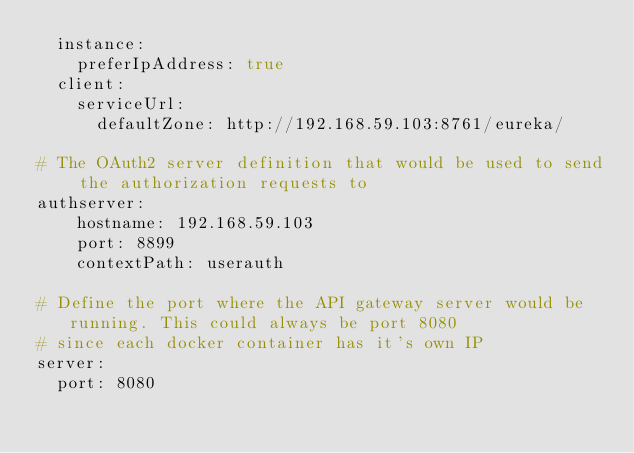<code> <loc_0><loc_0><loc_500><loc_500><_YAML_>  instance:
    preferIpAddress: true
  client:
    serviceUrl:
      defaultZone: http://192.168.59.103:8761/eureka/
      
# The OAuth2 server definition that would be used to send the authorization requests to
authserver:
    hostname: 192.168.59.103
    port: 8899
    contextPath: userauth
    
# Define the port where the API gateway server would be running. This could always be port 8080
# since each docker container has it's own IP
server:
  port: 8080
</code> 